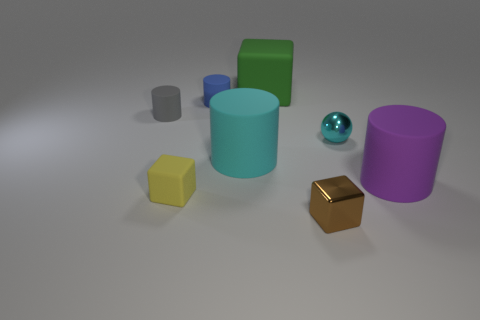Subtract all red balls. Subtract all gray blocks. How many balls are left? 1 Add 1 tiny yellow objects. How many objects exist? 9 Subtract all cubes. How many objects are left? 5 Subtract 1 yellow blocks. How many objects are left? 7 Subtract all small matte cylinders. Subtract all small metallic things. How many objects are left? 4 Add 7 tiny brown metallic blocks. How many tiny brown metallic blocks are left? 8 Add 6 blue rubber cylinders. How many blue rubber cylinders exist? 7 